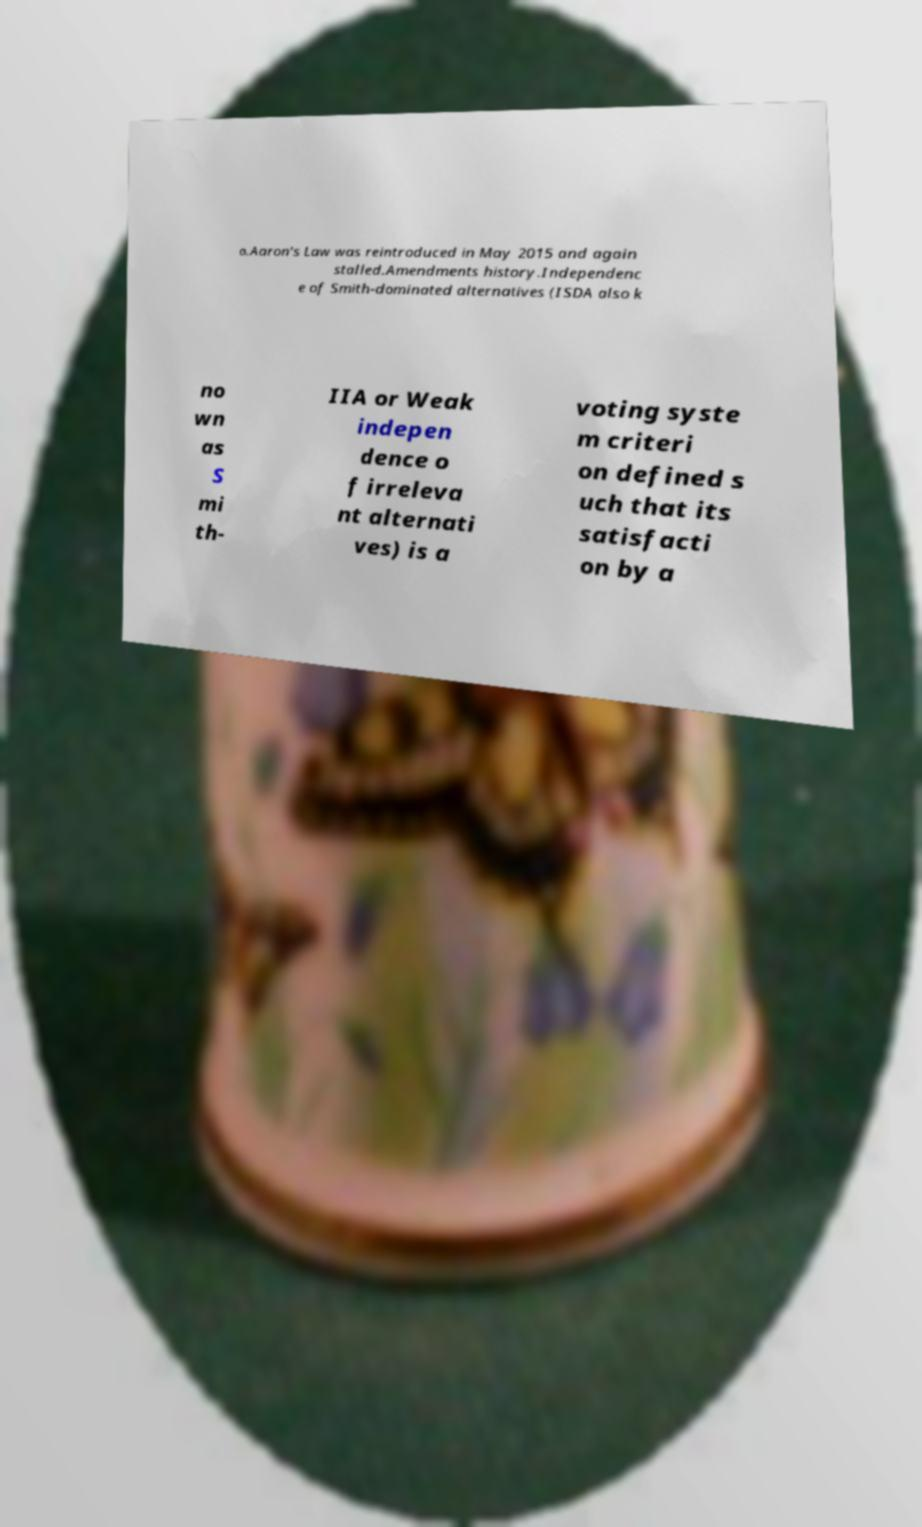Please identify and transcribe the text found in this image. o.Aaron's Law was reintroduced in May 2015 and again stalled.Amendments history.Independenc e of Smith-dominated alternatives (ISDA also k no wn as S mi th- IIA or Weak indepen dence o f irreleva nt alternati ves) is a voting syste m criteri on defined s uch that its satisfacti on by a 